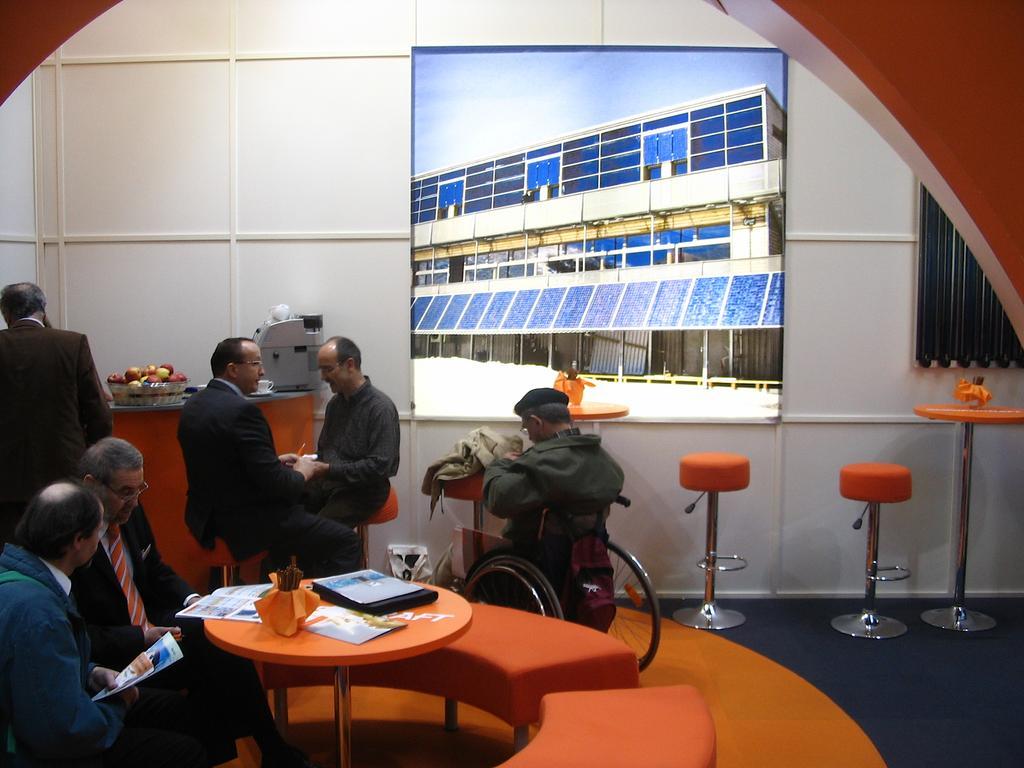Please provide a concise description of this image. As we can see in the image there is a wall, screen, few people and a table. On table there is a laptop. 